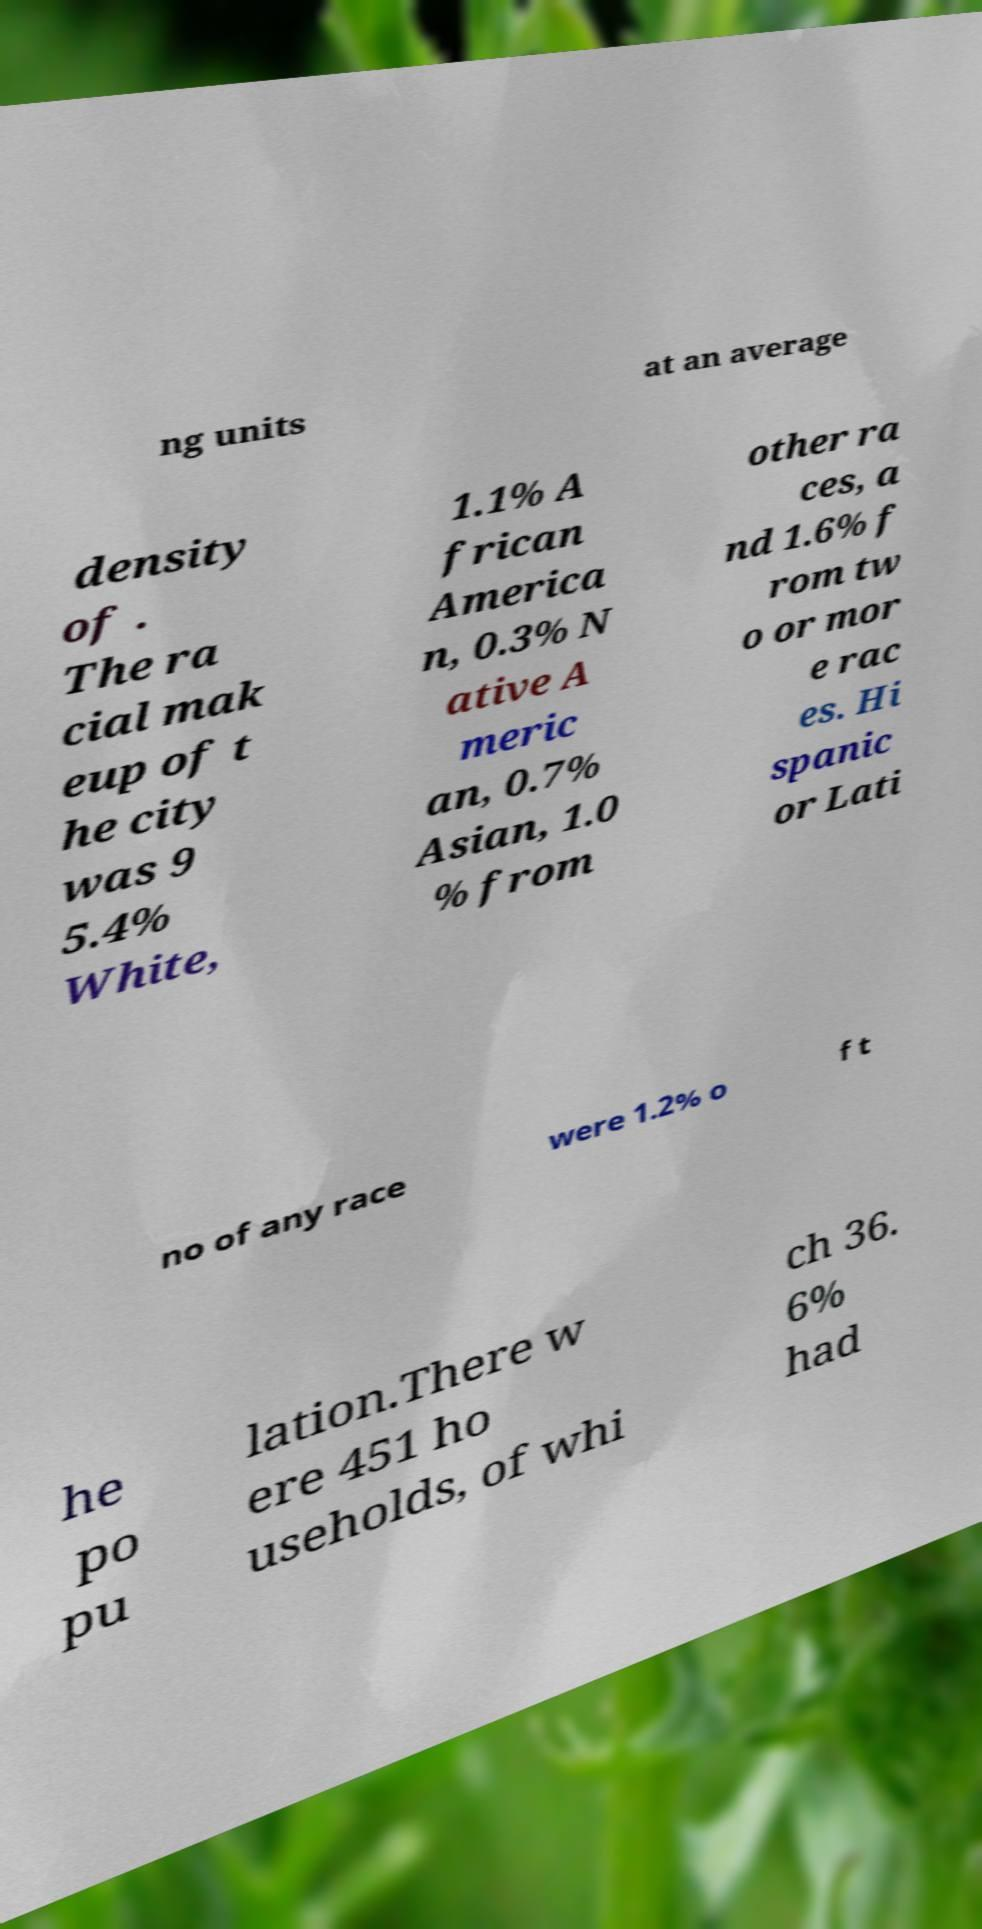I need the written content from this picture converted into text. Can you do that? ng units at an average density of . The ra cial mak eup of t he city was 9 5.4% White, 1.1% A frican America n, 0.3% N ative A meric an, 0.7% Asian, 1.0 % from other ra ces, a nd 1.6% f rom tw o or mor e rac es. Hi spanic or Lati no of any race were 1.2% o f t he po pu lation.There w ere 451 ho useholds, of whi ch 36. 6% had 